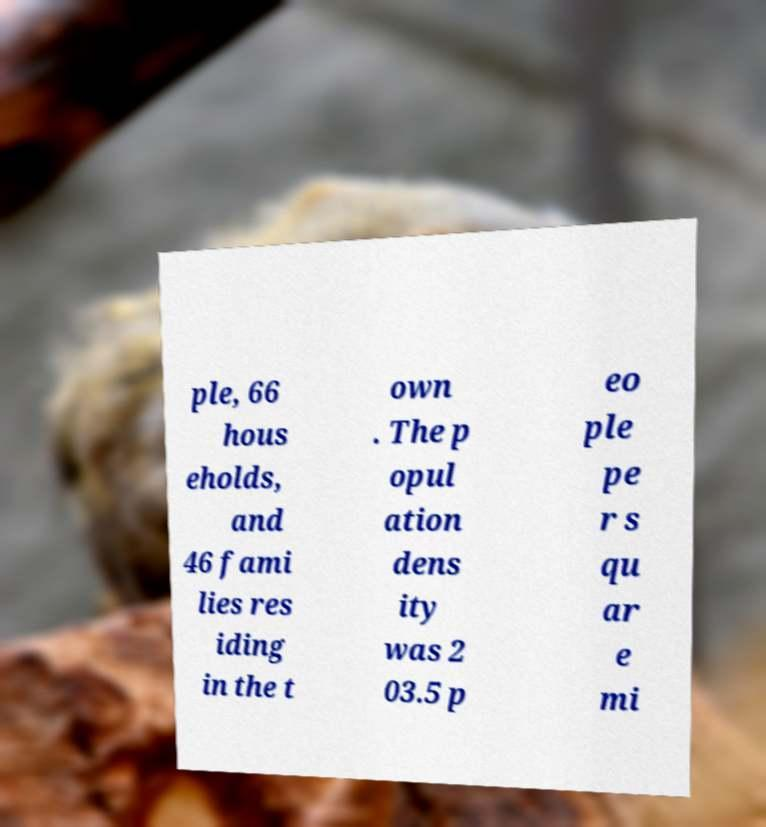I need the written content from this picture converted into text. Can you do that? ple, 66 hous eholds, and 46 fami lies res iding in the t own . The p opul ation dens ity was 2 03.5 p eo ple pe r s qu ar e mi 